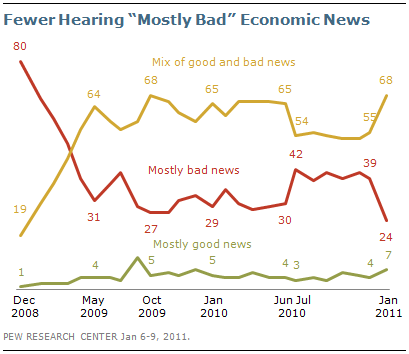Point out several critical features in this image. The yellow and red lines cross a total of 1 time. The color of a graph whose largest value is 80 is red. 